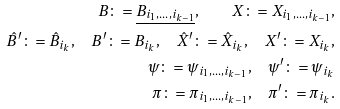Convert formula to latex. <formula><loc_0><loc_0><loc_500><loc_500>B \colon = \underline { B _ { i _ { 1 } , \dots , i _ { k - 1 } } } , \quad X \colon = X _ { i _ { 1 } , \dots , i _ { k - 1 } } , \\ \hat { B } ^ { \prime } \colon = \hat { B } _ { i _ { k } } , \quad B ^ { \prime } \colon = B _ { i _ { k } } , \quad \hat { X } ^ { \prime } \colon = \hat { X } _ { i _ { k } } , \quad X ^ { \prime } \colon = X _ { i _ { k } } , \\ \psi \colon = \psi _ { i _ { 1 } , \dots , i _ { k - 1 } } , \quad \psi ^ { \prime } \colon = \psi _ { i _ { k } } \\ \pi \colon = \pi _ { i _ { 1 } , \dots , i _ { k - 1 } } , \quad \pi ^ { \prime } \colon = \pi _ { i _ { k } } .</formula> 